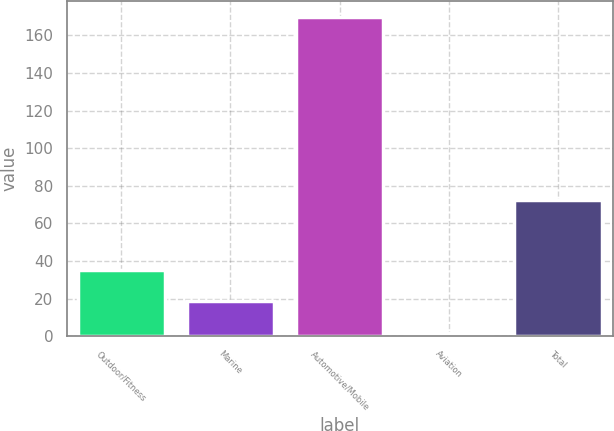Convert chart to OTSL. <chart><loc_0><loc_0><loc_500><loc_500><bar_chart><fcel>Outdoor/Fitness<fcel>Marine<fcel>Automotive/Mobile<fcel>Aviation<fcel>Total<nl><fcel>35.28<fcel>18.44<fcel>170<fcel>1.6<fcel>72.6<nl></chart> 